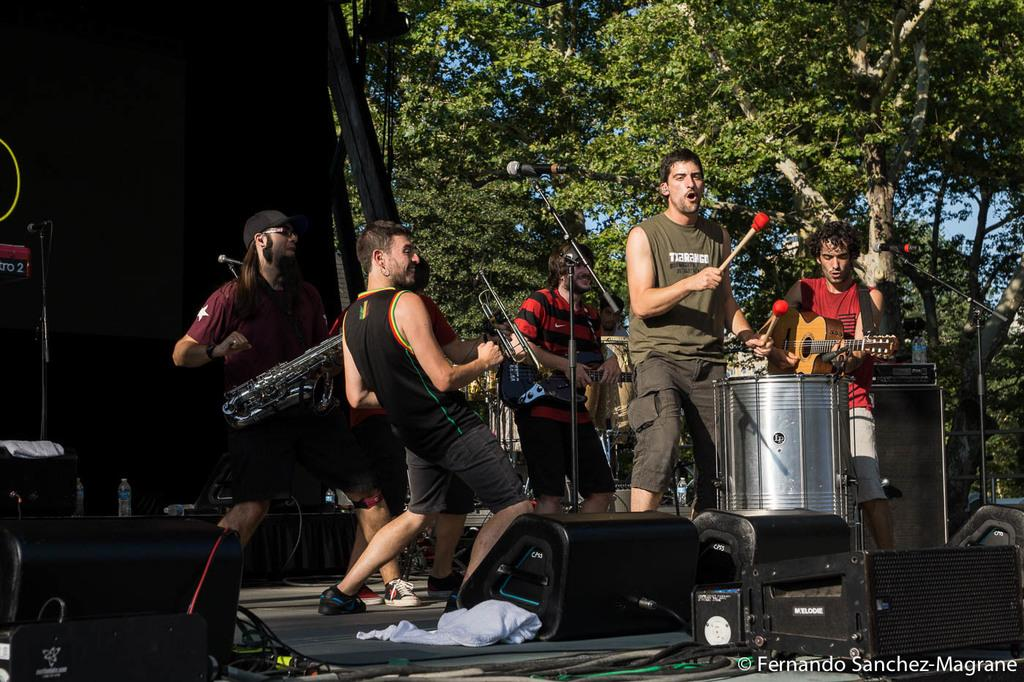What can be seen in the background of the image? There are trees in the background of the image. What part of the sky is visible through the trees? A partial part of the sky is visible through the trees. What are the people in the image doing? The persons in the image are playing musical instruments. Where are the musical instruments being played? The musical instruments are being played on a platform. Can you see any thumbs playing the musical instruments in the image? There is no mention of thumbs playing the musical instruments in the image; it is the persons who are playing them. Are there any bananas hanging from the trees in the background? There is no mention of bananas in the image; only trees are mentioned in the background. 